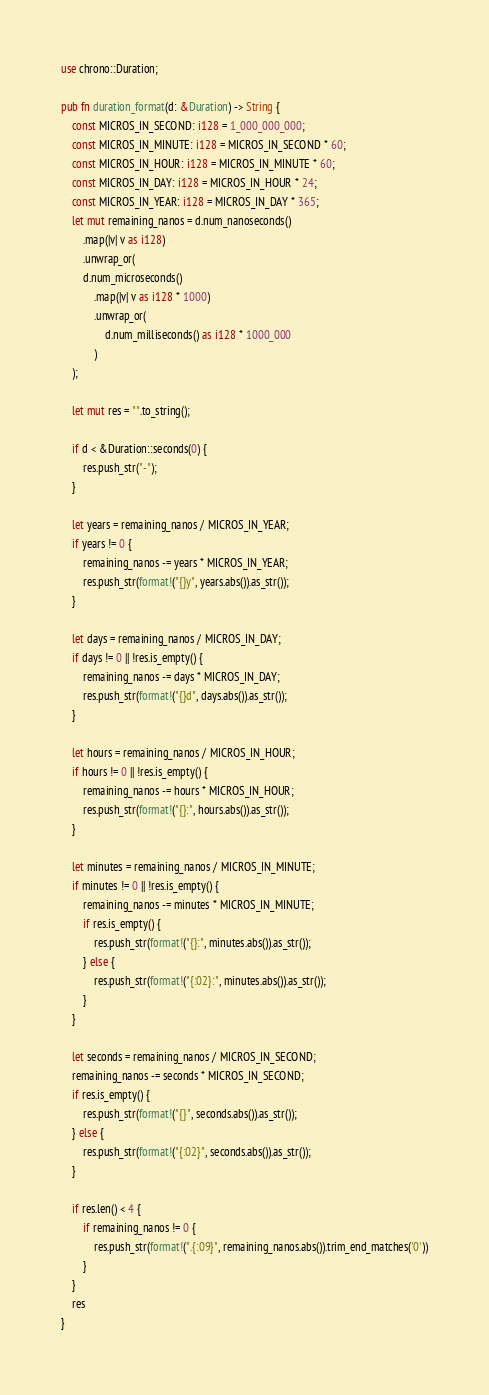<code> <loc_0><loc_0><loc_500><loc_500><_Rust_>use chrono::Duration;

pub fn duration_format(d: &Duration) -> String {
    const MICROS_IN_SECOND: i128 = 1_000_000_000;
    const MICROS_IN_MINUTE: i128 = MICROS_IN_SECOND * 60;
    const MICROS_IN_HOUR: i128 = MICROS_IN_MINUTE * 60;
    const MICROS_IN_DAY: i128 = MICROS_IN_HOUR * 24;
    const MICROS_IN_YEAR: i128 = MICROS_IN_DAY * 365;
    let mut remaining_nanos = d.num_nanoseconds()
        .map(|v| v as i128)
        .unwrap_or(
        d.num_microseconds()
            .map(|v| v as i128 * 1000)
            .unwrap_or(
                d.num_milliseconds() as i128 * 1000_000
            )
    );

    let mut res = "".to_string();

    if d < &Duration::seconds(0) {
        res.push_str("-");
    }

    let years = remaining_nanos / MICROS_IN_YEAR;
    if years != 0 {
        remaining_nanos -= years * MICROS_IN_YEAR;
        res.push_str(format!("{}y", years.abs()).as_str());
    }

    let days = remaining_nanos / MICROS_IN_DAY;
    if days != 0 || !res.is_empty() {
        remaining_nanos -= days * MICROS_IN_DAY;
        res.push_str(format!("{}d", days.abs()).as_str());
    }

    let hours = remaining_nanos / MICROS_IN_HOUR;
    if hours != 0 || !res.is_empty() {
        remaining_nanos -= hours * MICROS_IN_HOUR;
        res.push_str(format!("{}:", hours.abs()).as_str());
    }

    let minutes = remaining_nanos / MICROS_IN_MINUTE;
    if minutes != 0 || !res.is_empty() {
        remaining_nanos -= minutes * MICROS_IN_MINUTE;
        if res.is_empty() {
            res.push_str(format!("{}:", minutes.abs()).as_str());
        } else {
            res.push_str(format!("{:02}:", minutes.abs()).as_str());
        }
    }

    let seconds = remaining_nanos / MICROS_IN_SECOND;
    remaining_nanos -= seconds * MICROS_IN_SECOND;
    if res.is_empty() {
        res.push_str(format!("{}", seconds.abs()).as_str());
    } else {
        res.push_str(format!("{:02}", seconds.abs()).as_str());
    }

    if res.len() < 4 {
        if remaining_nanos != 0 {
            res.push_str(format!(".{:09}", remaining_nanos.abs()).trim_end_matches('0'))
        }
    }
    res
}
</code> 